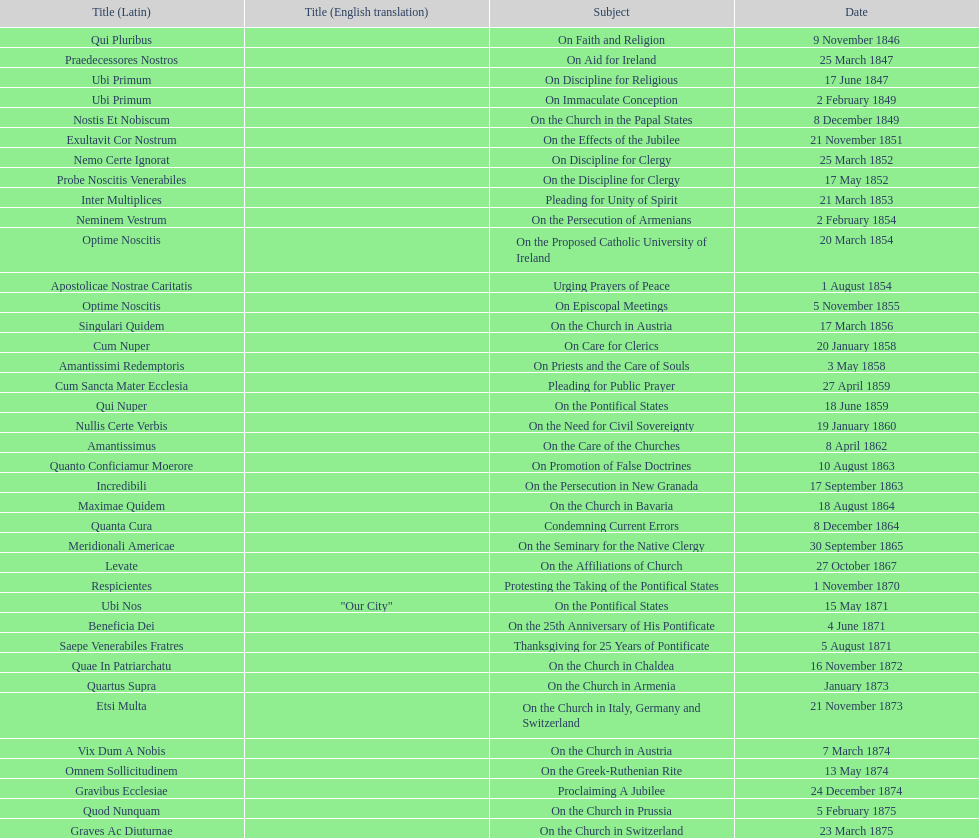How many encyclicals were issued by pope pius ix within the first ten years of his reign? 14. 